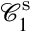Convert formula to latex. <formula><loc_0><loc_0><loc_500><loc_500>\mathcal { C } _ { 1 } ^ { s }</formula> 